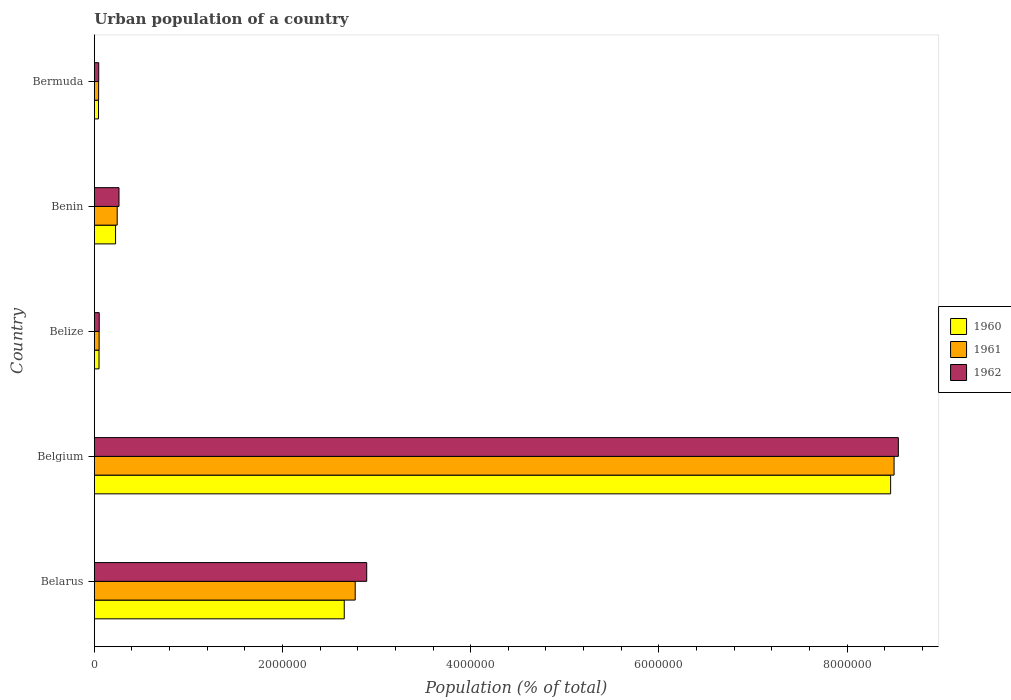How many groups of bars are there?
Provide a short and direct response. 5. Are the number of bars per tick equal to the number of legend labels?
Offer a very short reply. Yes. What is the label of the 5th group of bars from the top?
Your answer should be very brief. Belarus. What is the urban population in 1960 in Belgium?
Your response must be concise. 8.46e+06. Across all countries, what is the maximum urban population in 1962?
Keep it short and to the point. 8.55e+06. Across all countries, what is the minimum urban population in 1962?
Make the answer very short. 4.66e+04. In which country was the urban population in 1960 minimum?
Offer a very short reply. Bermuda. What is the total urban population in 1961 in the graph?
Offer a terse response. 1.16e+07. What is the difference between the urban population in 1962 in Belgium and that in Belize?
Make the answer very short. 8.49e+06. What is the difference between the urban population in 1960 in Belize and the urban population in 1961 in Belgium?
Offer a terse response. -8.45e+06. What is the average urban population in 1960 per country?
Offer a very short reply. 2.29e+06. What is the difference between the urban population in 1960 and urban population in 1962 in Belgium?
Provide a short and direct response. -8.22e+04. What is the ratio of the urban population in 1960 in Belgium to that in Benin?
Offer a terse response. 37.53. Is the urban population in 1960 in Belarus less than that in Benin?
Offer a terse response. No. Is the difference between the urban population in 1960 in Belgium and Belize greater than the difference between the urban population in 1962 in Belgium and Belize?
Your answer should be compact. No. What is the difference between the highest and the second highest urban population in 1960?
Give a very brief answer. 5.81e+06. What is the difference between the highest and the lowest urban population in 1961?
Keep it short and to the point. 8.45e+06. What does the 3rd bar from the bottom in Belize represents?
Provide a short and direct response. 1962. Is it the case that in every country, the sum of the urban population in 1962 and urban population in 1961 is greater than the urban population in 1960?
Ensure brevity in your answer.  Yes. How many bars are there?
Offer a very short reply. 15. Are all the bars in the graph horizontal?
Provide a succinct answer. Yes. What is the difference between two consecutive major ticks on the X-axis?
Your response must be concise. 2.00e+06. Are the values on the major ticks of X-axis written in scientific E-notation?
Provide a short and direct response. No. Does the graph contain any zero values?
Your answer should be compact. No. Where does the legend appear in the graph?
Give a very brief answer. Center right. How many legend labels are there?
Offer a terse response. 3. What is the title of the graph?
Your answer should be compact. Urban population of a country. What is the label or title of the X-axis?
Keep it short and to the point. Population (% of total). What is the Population (% of total) of 1960 in Belarus?
Provide a succinct answer. 2.66e+06. What is the Population (% of total) in 1961 in Belarus?
Provide a succinct answer. 2.77e+06. What is the Population (% of total) in 1962 in Belarus?
Your answer should be very brief. 2.90e+06. What is the Population (% of total) in 1960 in Belgium?
Offer a very short reply. 8.46e+06. What is the Population (% of total) in 1961 in Belgium?
Provide a succinct answer. 8.50e+06. What is the Population (% of total) of 1962 in Belgium?
Offer a terse response. 8.55e+06. What is the Population (% of total) of 1960 in Belize?
Provide a succinct answer. 4.97e+04. What is the Population (% of total) in 1961 in Belize?
Your response must be concise. 5.09e+04. What is the Population (% of total) of 1962 in Belize?
Your answer should be very brief. 5.20e+04. What is the Population (% of total) of 1960 in Benin?
Keep it short and to the point. 2.26e+05. What is the Population (% of total) in 1961 in Benin?
Make the answer very short. 2.43e+05. What is the Population (% of total) of 1962 in Benin?
Keep it short and to the point. 2.62e+05. What is the Population (% of total) in 1960 in Bermuda?
Offer a very short reply. 4.44e+04. What is the Population (% of total) in 1961 in Bermuda?
Make the answer very short. 4.55e+04. What is the Population (% of total) in 1962 in Bermuda?
Keep it short and to the point. 4.66e+04. Across all countries, what is the maximum Population (% of total) of 1960?
Offer a terse response. 8.46e+06. Across all countries, what is the maximum Population (% of total) of 1961?
Make the answer very short. 8.50e+06. Across all countries, what is the maximum Population (% of total) in 1962?
Your response must be concise. 8.55e+06. Across all countries, what is the minimum Population (% of total) of 1960?
Your answer should be very brief. 4.44e+04. Across all countries, what is the minimum Population (% of total) in 1961?
Keep it short and to the point. 4.55e+04. Across all countries, what is the minimum Population (% of total) of 1962?
Offer a terse response. 4.66e+04. What is the total Population (% of total) in 1960 in the graph?
Your response must be concise. 1.14e+07. What is the total Population (% of total) in 1961 in the graph?
Offer a very short reply. 1.16e+07. What is the total Population (% of total) of 1962 in the graph?
Offer a terse response. 1.18e+07. What is the difference between the Population (% of total) in 1960 in Belarus and that in Belgium?
Keep it short and to the point. -5.81e+06. What is the difference between the Population (% of total) in 1961 in Belarus and that in Belgium?
Give a very brief answer. -5.73e+06. What is the difference between the Population (% of total) in 1962 in Belarus and that in Belgium?
Your response must be concise. -5.65e+06. What is the difference between the Population (% of total) in 1960 in Belarus and that in Belize?
Ensure brevity in your answer.  2.61e+06. What is the difference between the Population (% of total) in 1961 in Belarus and that in Belize?
Make the answer very short. 2.72e+06. What is the difference between the Population (% of total) of 1962 in Belarus and that in Belize?
Ensure brevity in your answer.  2.84e+06. What is the difference between the Population (% of total) of 1960 in Belarus and that in Benin?
Your answer should be compact. 2.43e+06. What is the difference between the Population (% of total) of 1961 in Belarus and that in Benin?
Provide a short and direct response. 2.53e+06. What is the difference between the Population (% of total) of 1962 in Belarus and that in Benin?
Keep it short and to the point. 2.63e+06. What is the difference between the Population (% of total) in 1960 in Belarus and that in Bermuda?
Make the answer very short. 2.61e+06. What is the difference between the Population (% of total) of 1961 in Belarus and that in Bermuda?
Provide a short and direct response. 2.73e+06. What is the difference between the Population (% of total) in 1962 in Belarus and that in Bermuda?
Give a very brief answer. 2.85e+06. What is the difference between the Population (% of total) of 1960 in Belgium and that in Belize?
Offer a very short reply. 8.41e+06. What is the difference between the Population (% of total) in 1961 in Belgium and that in Belize?
Provide a succinct answer. 8.45e+06. What is the difference between the Population (% of total) of 1962 in Belgium and that in Belize?
Your answer should be very brief. 8.49e+06. What is the difference between the Population (% of total) of 1960 in Belgium and that in Benin?
Your answer should be compact. 8.24e+06. What is the difference between the Population (% of total) of 1961 in Belgium and that in Benin?
Provide a succinct answer. 8.26e+06. What is the difference between the Population (% of total) in 1962 in Belgium and that in Benin?
Offer a very short reply. 8.28e+06. What is the difference between the Population (% of total) of 1960 in Belgium and that in Bermuda?
Keep it short and to the point. 8.42e+06. What is the difference between the Population (% of total) of 1961 in Belgium and that in Bermuda?
Provide a succinct answer. 8.45e+06. What is the difference between the Population (% of total) in 1962 in Belgium and that in Bermuda?
Make the answer very short. 8.50e+06. What is the difference between the Population (% of total) of 1960 in Belize and that in Benin?
Keep it short and to the point. -1.76e+05. What is the difference between the Population (% of total) of 1961 in Belize and that in Benin?
Your response must be concise. -1.92e+05. What is the difference between the Population (% of total) in 1962 in Belize and that in Benin?
Provide a short and direct response. -2.10e+05. What is the difference between the Population (% of total) of 1960 in Belize and that in Bermuda?
Offer a terse response. 5342. What is the difference between the Population (% of total) of 1961 in Belize and that in Bermuda?
Ensure brevity in your answer.  5373. What is the difference between the Population (% of total) of 1962 in Belize and that in Bermuda?
Provide a succinct answer. 5415. What is the difference between the Population (% of total) in 1960 in Benin and that in Bermuda?
Give a very brief answer. 1.81e+05. What is the difference between the Population (% of total) of 1961 in Benin and that in Bermuda?
Ensure brevity in your answer.  1.98e+05. What is the difference between the Population (% of total) of 1962 in Benin and that in Bermuda?
Give a very brief answer. 2.15e+05. What is the difference between the Population (% of total) in 1960 in Belarus and the Population (% of total) in 1961 in Belgium?
Ensure brevity in your answer.  -5.84e+06. What is the difference between the Population (% of total) in 1960 in Belarus and the Population (% of total) in 1962 in Belgium?
Offer a terse response. -5.89e+06. What is the difference between the Population (% of total) in 1961 in Belarus and the Population (% of total) in 1962 in Belgium?
Give a very brief answer. -5.77e+06. What is the difference between the Population (% of total) of 1960 in Belarus and the Population (% of total) of 1961 in Belize?
Make the answer very short. 2.61e+06. What is the difference between the Population (% of total) in 1960 in Belarus and the Population (% of total) in 1962 in Belize?
Your answer should be compact. 2.60e+06. What is the difference between the Population (% of total) of 1961 in Belarus and the Population (% of total) of 1962 in Belize?
Your answer should be very brief. 2.72e+06. What is the difference between the Population (% of total) in 1960 in Belarus and the Population (% of total) in 1961 in Benin?
Offer a terse response. 2.41e+06. What is the difference between the Population (% of total) of 1960 in Belarus and the Population (% of total) of 1962 in Benin?
Give a very brief answer. 2.39e+06. What is the difference between the Population (% of total) in 1961 in Belarus and the Population (% of total) in 1962 in Benin?
Your answer should be very brief. 2.51e+06. What is the difference between the Population (% of total) of 1960 in Belarus and the Population (% of total) of 1961 in Bermuda?
Provide a short and direct response. 2.61e+06. What is the difference between the Population (% of total) in 1960 in Belarus and the Population (% of total) in 1962 in Bermuda?
Ensure brevity in your answer.  2.61e+06. What is the difference between the Population (% of total) of 1961 in Belarus and the Population (% of total) of 1962 in Bermuda?
Your answer should be very brief. 2.73e+06. What is the difference between the Population (% of total) of 1960 in Belgium and the Population (% of total) of 1961 in Belize?
Provide a succinct answer. 8.41e+06. What is the difference between the Population (% of total) in 1960 in Belgium and the Population (% of total) in 1962 in Belize?
Offer a terse response. 8.41e+06. What is the difference between the Population (% of total) in 1961 in Belgium and the Population (% of total) in 1962 in Belize?
Provide a succinct answer. 8.45e+06. What is the difference between the Population (% of total) in 1960 in Belgium and the Population (% of total) in 1961 in Benin?
Provide a short and direct response. 8.22e+06. What is the difference between the Population (% of total) of 1960 in Belgium and the Population (% of total) of 1962 in Benin?
Make the answer very short. 8.20e+06. What is the difference between the Population (% of total) in 1961 in Belgium and the Population (% of total) in 1962 in Benin?
Make the answer very short. 8.24e+06. What is the difference between the Population (% of total) in 1960 in Belgium and the Population (% of total) in 1961 in Bermuda?
Your response must be concise. 8.42e+06. What is the difference between the Population (% of total) of 1960 in Belgium and the Population (% of total) of 1962 in Bermuda?
Ensure brevity in your answer.  8.42e+06. What is the difference between the Population (% of total) in 1961 in Belgium and the Population (% of total) in 1962 in Bermuda?
Ensure brevity in your answer.  8.45e+06. What is the difference between the Population (% of total) in 1960 in Belize and the Population (% of total) in 1961 in Benin?
Your answer should be very brief. -1.93e+05. What is the difference between the Population (% of total) in 1960 in Belize and the Population (% of total) in 1962 in Benin?
Ensure brevity in your answer.  -2.12e+05. What is the difference between the Population (% of total) in 1961 in Belize and the Population (% of total) in 1962 in Benin?
Your response must be concise. -2.11e+05. What is the difference between the Population (% of total) in 1960 in Belize and the Population (% of total) in 1961 in Bermuda?
Ensure brevity in your answer.  4242. What is the difference between the Population (% of total) of 1960 in Belize and the Population (% of total) of 1962 in Bermuda?
Your answer should be very brief. 3142. What is the difference between the Population (% of total) in 1961 in Belize and the Population (% of total) in 1962 in Bermuda?
Provide a short and direct response. 4273. What is the difference between the Population (% of total) in 1960 in Benin and the Population (% of total) in 1961 in Bermuda?
Provide a succinct answer. 1.80e+05. What is the difference between the Population (% of total) of 1960 in Benin and the Population (% of total) of 1962 in Bermuda?
Offer a very short reply. 1.79e+05. What is the difference between the Population (% of total) in 1961 in Benin and the Population (% of total) in 1962 in Bermuda?
Provide a succinct answer. 1.96e+05. What is the average Population (% of total) of 1960 per country?
Provide a short and direct response. 2.29e+06. What is the average Population (% of total) in 1961 per country?
Your response must be concise. 2.32e+06. What is the average Population (% of total) in 1962 per country?
Offer a very short reply. 2.36e+06. What is the difference between the Population (% of total) in 1960 and Population (% of total) in 1961 in Belarus?
Provide a succinct answer. -1.16e+05. What is the difference between the Population (% of total) in 1960 and Population (% of total) in 1962 in Belarus?
Keep it short and to the point. -2.39e+05. What is the difference between the Population (% of total) of 1961 and Population (% of total) of 1962 in Belarus?
Offer a terse response. -1.22e+05. What is the difference between the Population (% of total) of 1960 and Population (% of total) of 1961 in Belgium?
Keep it short and to the point. -3.68e+04. What is the difference between the Population (% of total) of 1960 and Population (% of total) of 1962 in Belgium?
Provide a short and direct response. -8.22e+04. What is the difference between the Population (% of total) in 1961 and Population (% of total) in 1962 in Belgium?
Give a very brief answer. -4.54e+04. What is the difference between the Population (% of total) in 1960 and Population (% of total) in 1961 in Belize?
Ensure brevity in your answer.  -1131. What is the difference between the Population (% of total) of 1960 and Population (% of total) of 1962 in Belize?
Ensure brevity in your answer.  -2273. What is the difference between the Population (% of total) of 1961 and Population (% of total) of 1962 in Belize?
Provide a succinct answer. -1142. What is the difference between the Population (% of total) of 1960 and Population (% of total) of 1961 in Benin?
Offer a very short reply. -1.75e+04. What is the difference between the Population (% of total) of 1960 and Population (% of total) of 1962 in Benin?
Give a very brief answer. -3.66e+04. What is the difference between the Population (% of total) of 1961 and Population (% of total) of 1962 in Benin?
Make the answer very short. -1.90e+04. What is the difference between the Population (% of total) in 1960 and Population (% of total) in 1961 in Bermuda?
Give a very brief answer. -1100. What is the difference between the Population (% of total) in 1960 and Population (% of total) in 1962 in Bermuda?
Keep it short and to the point. -2200. What is the difference between the Population (% of total) in 1961 and Population (% of total) in 1962 in Bermuda?
Provide a short and direct response. -1100. What is the ratio of the Population (% of total) in 1960 in Belarus to that in Belgium?
Your response must be concise. 0.31. What is the ratio of the Population (% of total) in 1961 in Belarus to that in Belgium?
Provide a short and direct response. 0.33. What is the ratio of the Population (% of total) of 1962 in Belarus to that in Belgium?
Offer a terse response. 0.34. What is the ratio of the Population (% of total) in 1960 in Belarus to that in Belize?
Your answer should be very brief. 53.4. What is the ratio of the Population (% of total) in 1961 in Belarus to that in Belize?
Keep it short and to the point. 54.5. What is the ratio of the Population (% of total) of 1962 in Belarus to that in Belize?
Your answer should be very brief. 55.66. What is the ratio of the Population (% of total) of 1960 in Belarus to that in Benin?
Provide a succinct answer. 11.78. What is the ratio of the Population (% of total) in 1961 in Belarus to that in Benin?
Make the answer very short. 11.41. What is the ratio of the Population (% of total) in 1962 in Belarus to that in Benin?
Provide a short and direct response. 11.05. What is the ratio of the Population (% of total) of 1960 in Belarus to that in Bermuda?
Provide a short and direct response. 59.83. What is the ratio of the Population (% of total) in 1961 in Belarus to that in Bermuda?
Offer a very short reply. 60.94. What is the ratio of the Population (% of total) in 1962 in Belarus to that in Bermuda?
Offer a very short reply. 62.13. What is the ratio of the Population (% of total) in 1960 in Belgium to that in Belize?
Provide a short and direct response. 170.14. What is the ratio of the Population (% of total) of 1961 in Belgium to that in Belize?
Your response must be concise. 167.08. What is the ratio of the Population (% of total) in 1962 in Belgium to that in Belize?
Provide a short and direct response. 164.29. What is the ratio of the Population (% of total) of 1960 in Belgium to that in Benin?
Give a very brief answer. 37.53. What is the ratio of the Population (% of total) of 1961 in Belgium to that in Benin?
Your answer should be very brief. 34.97. What is the ratio of the Population (% of total) of 1962 in Belgium to that in Benin?
Make the answer very short. 32.61. What is the ratio of the Population (% of total) in 1960 in Belgium to that in Bermuda?
Offer a very short reply. 190.62. What is the ratio of the Population (% of total) of 1961 in Belgium to that in Bermuda?
Offer a very short reply. 186.82. What is the ratio of the Population (% of total) of 1962 in Belgium to that in Bermuda?
Ensure brevity in your answer.  183.38. What is the ratio of the Population (% of total) of 1960 in Belize to that in Benin?
Keep it short and to the point. 0.22. What is the ratio of the Population (% of total) in 1961 in Belize to that in Benin?
Offer a terse response. 0.21. What is the ratio of the Population (% of total) in 1962 in Belize to that in Benin?
Provide a succinct answer. 0.2. What is the ratio of the Population (% of total) of 1960 in Belize to that in Bermuda?
Offer a terse response. 1.12. What is the ratio of the Population (% of total) in 1961 in Belize to that in Bermuda?
Offer a very short reply. 1.12. What is the ratio of the Population (% of total) of 1962 in Belize to that in Bermuda?
Ensure brevity in your answer.  1.12. What is the ratio of the Population (% of total) in 1960 in Benin to that in Bermuda?
Keep it short and to the point. 5.08. What is the ratio of the Population (% of total) in 1961 in Benin to that in Bermuda?
Offer a terse response. 5.34. What is the ratio of the Population (% of total) in 1962 in Benin to that in Bermuda?
Make the answer very short. 5.62. What is the difference between the highest and the second highest Population (% of total) of 1960?
Ensure brevity in your answer.  5.81e+06. What is the difference between the highest and the second highest Population (% of total) in 1961?
Make the answer very short. 5.73e+06. What is the difference between the highest and the second highest Population (% of total) in 1962?
Provide a succinct answer. 5.65e+06. What is the difference between the highest and the lowest Population (% of total) in 1960?
Provide a succinct answer. 8.42e+06. What is the difference between the highest and the lowest Population (% of total) in 1961?
Give a very brief answer. 8.45e+06. What is the difference between the highest and the lowest Population (% of total) of 1962?
Provide a short and direct response. 8.50e+06. 